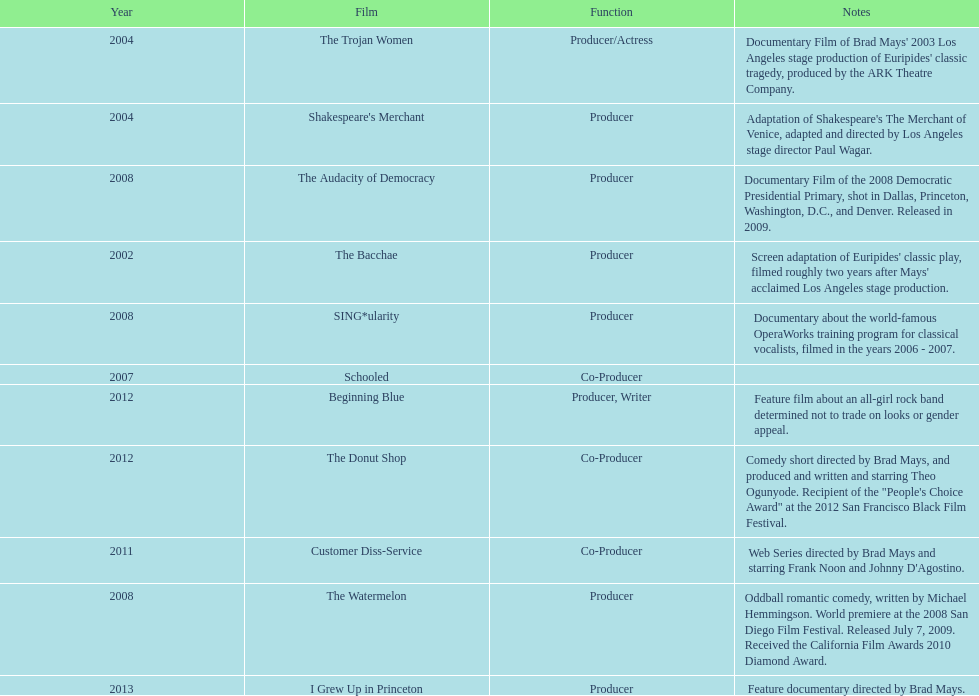In which year did ms. starfelt produce the most films? 2008. 